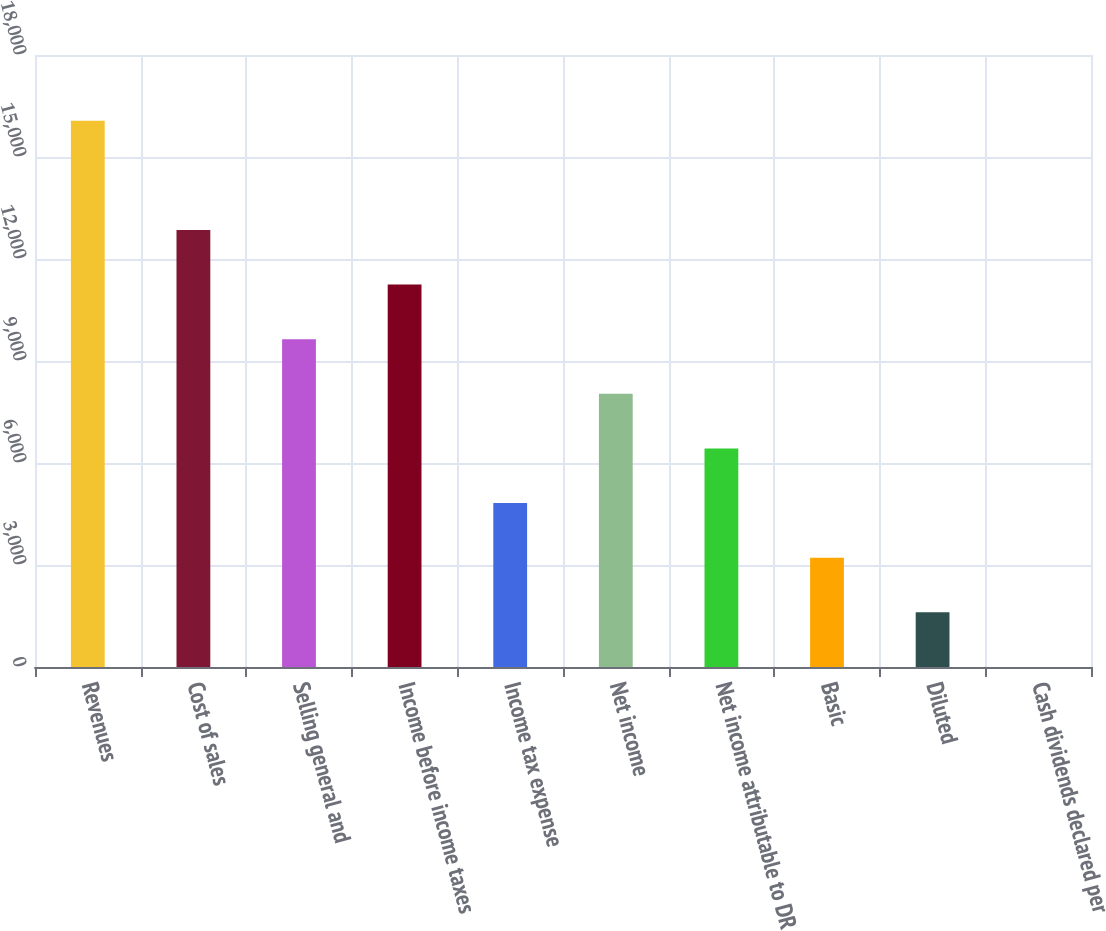Convert chart. <chart><loc_0><loc_0><loc_500><loc_500><bar_chart><fcel>Revenues<fcel>Cost of sales<fcel>Selling general and<fcel>Income before income taxes<fcel>Income tax expense<fcel>Net income<fcel>Net income attributable to DR<fcel>Basic<fcel>Diluted<fcel>Cash dividends declared per<nl><fcel>16068<fcel>12854.5<fcel>9641<fcel>11247.8<fcel>4820.75<fcel>8034.25<fcel>6427.5<fcel>3214<fcel>1607.25<fcel>0.5<nl></chart> 